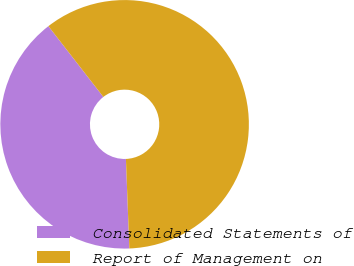Convert chart to OTSL. <chart><loc_0><loc_0><loc_500><loc_500><pie_chart><fcel>Consolidated Statements of<fcel>Report of Management on<nl><fcel>40.1%<fcel>59.9%<nl></chart> 